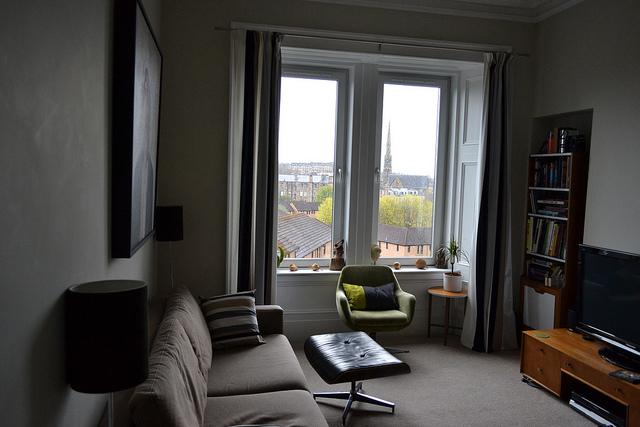What color is the left side of the pillow sitting on the single seat? yellow 